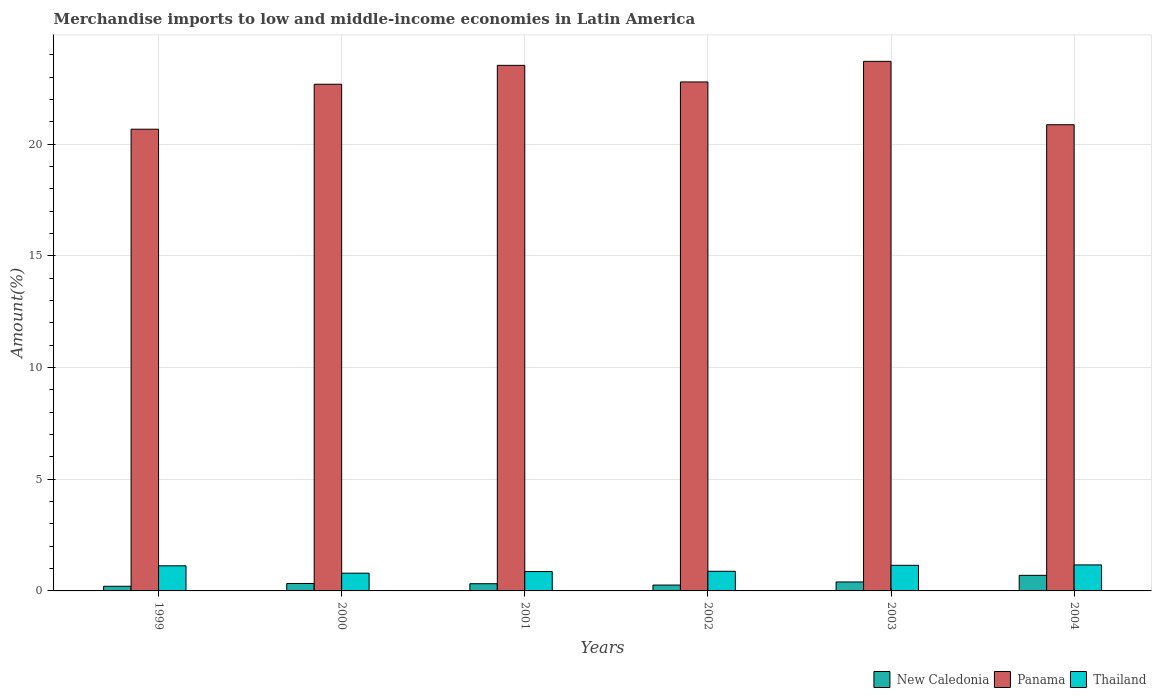How many different coloured bars are there?
Provide a short and direct response. 3. How many groups of bars are there?
Offer a terse response. 6. Are the number of bars per tick equal to the number of legend labels?
Your answer should be very brief. Yes. How many bars are there on the 3rd tick from the left?
Offer a terse response. 3. What is the percentage of amount earned from merchandise imports in New Caledonia in 2002?
Provide a short and direct response. 0.26. Across all years, what is the maximum percentage of amount earned from merchandise imports in Thailand?
Ensure brevity in your answer.  1.16. Across all years, what is the minimum percentage of amount earned from merchandise imports in Thailand?
Offer a very short reply. 0.79. In which year was the percentage of amount earned from merchandise imports in Thailand maximum?
Offer a very short reply. 2004. What is the total percentage of amount earned from merchandise imports in New Caledonia in the graph?
Your answer should be compact. 2.23. What is the difference between the percentage of amount earned from merchandise imports in Thailand in 2003 and that in 2004?
Your answer should be very brief. -0.02. What is the difference between the percentage of amount earned from merchandise imports in Panama in 2000 and the percentage of amount earned from merchandise imports in New Caledonia in 2003?
Keep it short and to the point. 22.28. What is the average percentage of amount earned from merchandise imports in New Caledonia per year?
Give a very brief answer. 0.37. In the year 2002, what is the difference between the percentage of amount earned from merchandise imports in Thailand and percentage of amount earned from merchandise imports in New Caledonia?
Make the answer very short. 0.62. In how many years, is the percentage of amount earned from merchandise imports in Thailand greater than 3 %?
Give a very brief answer. 0. What is the ratio of the percentage of amount earned from merchandise imports in New Caledonia in 2002 to that in 2003?
Your response must be concise. 0.66. Is the percentage of amount earned from merchandise imports in Panama in 2000 less than that in 2004?
Make the answer very short. No. Is the difference between the percentage of amount earned from merchandise imports in Thailand in 2003 and 2004 greater than the difference between the percentage of amount earned from merchandise imports in New Caledonia in 2003 and 2004?
Ensure brevity in your answer.  Yes. What is the difference between the highest and the second highest percentage of amount earned from merchandise imports in Panama?
Give a very brief answer. 0.18. What is the difference between the highest and the lowest percentage of amount earned from merchandise imports in Thailand?
Your response must be concise. 0.37. What does the 1st bar from the left in 2000 represents?
Provide a succinct answer. New Caledonia. What does the 2nd bar from the right in 2001 represents?
Give a very brief answer. Panama. How many years are there in the graph?
Provide a short and direct response. 6. Does the graph contain any zero values?
Offer a terse response. No. Does the graph contain grids?
Offer a terse response. Yes. What is the title of the graph?
Your answer should be very brief. Merchandise imports to low and middle-income economies in Latin America. Does "Montenegro" appear as one of the legend labels in the graph?
Keep it short and to the point. No. What is the label or title of the Y-axis?
Make the answer very short. Amount(%). What is the Amount(%) of New Caledonia in 1999?
Offer a terse response. 0.21. What is the Amount(%) of Panama in 1999?
Make the answer very short. 20.67. What is the Amount(%) in Thailand in 1999?
Offer a terse response. 1.12. What is the Amount(%) in New Caledonia in 2000?
Offer a terse response. 0.33. What is the Amount(%) in Panama in 2000?
Your response must be concise. 22.68. What is the Amount(%) of Thailand in 2000?
Your response must be concise. 0.79. What is the Amount(%) in New Caledonia in 2001?
Ensure brevity in your answer.  0.32. What is the Amount(%) of Panama in 2001?
Your answer should be very brief. 23.52. What is the Amount(%) of Thailand in 2001?
Provide a succinct answer. 0.87. What is the Amount(%) of New Caledonia in 2002?
Your answer should be very brief. 0.26. What is the Amount(%) in Panama in 2002?
Give a very brief answer. 22.78. What is the Amount(%) in Thailand in 2002?
Give a very brief answer. 0.88. What is the Amount(%) in New Caledonia in 2003?
Keep it short and to the point. 0.4. What is the Amount(%) of Panama in 2003?
Ensure brevity in your answer.  23.7. What is the Amount(%) in Thailand in 2003?
Your answer should be compact. 1.15. What is the Amount(%) of New Caledonia in 2004?
Offer a terse response. 0.7. What is the Amount(%) in Panama in 2004?
Offer a terse response. 20.87. What is the Amount(%) in Thailand in 2004?
Offer a very short reply. 1.16. Across all years, what is the maximum Amount(%) of New Caledonia?
Offer a very short reply. 0.7. Across all years, what is the maximum Amount(%) of Panama?
Your answer should be very brief. 23.7. Across all years, what is the maximum Amount(%) in Thailand?
Make the answer very short. 1.16. Across all years, what is the minimum Amount(%) in New Caledonia?
Give a very brief answer. 0.21. Across all years, what is the minimum Amount(%) of Panama?
Offer a terse response. 20.67. Across all years, what is the minimum Amount(%) of Thailand?
Make the answer very short. 0.79. What is the total Amount(%) of New Caledonia in the graph?
Your response must be concise. 2.23. What is the total Amount(%) in Panama in the graph?
Give a very brief answer. 134.22. What is the total Amount(%) of Thailand in the graph?
Offer a terse response. 5.98. What is the difference between the Amount(%) in New Caledonia in 1999 and that in 2000?
Provide a succinct answer. -0.13. What is the difference between the Amount(%) in Panama in 1999 and that in 2000?
Your answer should be very brief. -2.01. What is the difference between the Amount(%) of Thailand in 1999 and that in 2000?
Make the answer very short. 0.33. What is the difference between the Amount(%) of New Caledonia in 1999 and that in 2001?
Your answer should be very brief. -0.11. What is the difference between the Amount(%) in Panama in 1999 and that in 2001?
Your response must be concise. -2.86. What is the difference between the Amount(%) of Thailand in 1999 and that in 2001?
Your answer should be compact. 0.26. What is the difference between the Amount(%) of New Caledonia in 1999 and that in 2002?
Offer a terse response. -0.05. What is the difference between the Amount(%) of Panama in 1999 and that in 2002?
Provide a succinct answer. -2.12. What is the difference between the Amount(%) in Thailand in 1999 and that in 2002?
Provide a short and direct response. 0.24. What is the difference between the Amount(%) in New Caledonia in 1999 and that in 2003?
Ensure brevity in your answer.  -0.19. What is the difference between the Amount(%) of Panama in 1999 and that in 2003?
Keep it short and to the point. -3.04. What is the difference between the Amount(%) in Thailand in 1999 and that in 2003?
Provide a short and direct response. -0.02. What is the difference between the Amount(%) in New Caledonia in 1999 and that in 2004?
Offer a very short reply. -0.49. What is the difference between the Amount(%) of Panama in 1999 and that in 2004?
Give a very brief answer. -0.2. What is the difference between the Amount(%) of Thailand in 1999 and that in 2004?
Provide a short and direct response. -0.04. What is the difference between the Amount(%) of New Caledonia in 2000 and that in 2001?
Your answer should be compact. 0.01. What is the difference between the Amount(%) of Panama in 2000 and that in 2001?
Your answer should be very brief. -0.85. What is the difference between the Amount(%) of Thailand in 2000 and that in 2001?
Your response must be concise. -0.07. What is the difference between the Amount(%) of New Caledonia in 2000 and that in 2002?
Offer a very short reply. 0.07. What is the difference between the Amount(%) in Panama in 2000 and that in 2002?
Your answer should be very brief. -0.1. What is the difference between the Amount(%) of Thailand in 2000 and that in 2002?
Make the answer very short. -0.08. What is the difference between the Amount(%) of New Caledonia in 2000 and that in 2003?
Your response must be concise. -0.07. What is the difference between the Amount(%) in Panama in 2000 and that in 2003?
Your answer should be compact. -1.02. What is the difference between the Amount(%) in Thailand in 2000 and that in 2003?
Your response must be concise. -0.35. What is the difference between the Amount(%) in New Caledonia in 2000 and that in 2004?
Give a very brief answer. -0.36. What is the difference between the Amount(%) of Panama in 2000 and that in 2004?
Give a very brief answer. 1.81. What is the difference between the Amount(%) in Thailand in 2000 and that in 2004?
Offer a very short reply. -0.37. What is the difference between the Amount(%) of New Caledonia in 2001 and that in 2002?
Your answer should be compact. 0.06. What is the difference between the Amount(%) in Panama in 2001 and that in 2002?
Keep it short and to the point. 0.74. What is the difference between the Amount(%) in Thailand in 2001 and that in 2002?
Provide a short and direct response. -0.01. What is the difference between the Amount(%) of New Caledonia in 2001 and that in 2003?
Your answer should be very brief. -0.08. What is the difference between the Amount(%) of Panama in 2001 and that in 2003?
Your answer should be very brief. -0.18. What is the difference between the Amount(%) of Thailand in 2001 and that in 2003?
Give a very brief answer. -0.28. What is the difference between the Amount(%) in New Caledonia in 2001 and that in 2004?
Provide a succinct answer. -0.38. What is the difference between the Amount(%) in Panama in 2001 and that in 2004?
Make the answer very short. 2.66. What is the difference between the Amount(%) in Thailand in 2001 and that in 2004?
Provide a short and direct response. -0.3. What is the difference between the Amount(%) of New Caledonia in 2002 and that in 2003?
Offer a very short reply. -0.14. What is the difference between the Amount(%) in Panama in 2002 and that in 2003?
Ensure brevity in your answer.  -0.92. What is the difference between the Amount(%) of Thailand in 2002 and that in 2003?
Provide a short and direct response. -0.27. What is the difference between the Amount(%) of New Caledonia in 2002 and that in 2004?
Keep it short and to the point. -0.43. What is the difference between the Amount(%) of Panama in 2002 and that in 2004?
Keep it short and to the point. 1.92. What is the difference between the Amount(%) in Thailand in 2002 and that in 2004?
Make the answer very short. -0.28. What is the difference between the Amount(%) of New Caledonia in 2003 and that in 2004?
Ensure brevity in your answer.  -0.3. What is the difference between the Amount(%) in Panama in 2003 and that in 2004?
Offer a very short reply. 2.84. What is the difference between the Amount(%) of Thailand in 2003 and that in 2004?
Provide a succinct answer. -0.02. What is the difference between the Amount(%) of New Caledonia in 1999 and the Amount(%) of Panama in 2000?
Your answer should be compact. -22.47. What is the difference between the Amount(%) of New Caledonia in 1999 and the Amount(%) of Thailand in 2000?
Offer a terse response. -0.59. What is the difference between the Amount(%) of Panama in 1999 and the Amount(%) of Thailand in 2000?
Offer a very short reply. 19.87. What is the difference between the Amount(%) in New Caledonia in 1999 and the Amount(%) in Panama in 2001?
Keep it short and to the point. -23.32. What is the difference between the Amount(%) in New Caledonia in 1999 and the Amount(%) in Thailand in 2001?
Give a very brief answer. -0.66. What is the difference between the Amount(%) in Panama in 1999 and the Amount(%) in Thailand in 2001?
Your answer should be very brief. 19.8. What is the difference between the Amount(%) in New Caledonia in 1999 and the Amount(%) in Panama in 2002?
Your response must be concise. -22.57. What is the difference between the Amount(%) of New Caledonia in 1999 and the Amount(%) of Thailand in 2002?
Provide a short and direct response. -0.67. What is the difference between the Amount(%) of Panama in 1999 and the Amount(%) of Thailand in 2002?
Provide a short and direct response. 19.79. What is the difference between the Amount(%) of New Caledonia in 1999 and the Amount(%) of Panama in 2003?
Provide a short and direct response. -23.5. What is the difference between the Amount(%) in New Caledonia in 1999 and the Amount(%) in Thailand in 2003?
Your answer should be very brief. -0.94. What is the difference between the Amount(%) in Panama in 1999 and the Amount(%) in Thailand in 2003?
Keep it short and to the point. 19.52. What is the difference between the Amount(%) in New Caledonia in 1999 and the Amount(%) in Panama in 2004?
Your response must be concise. -20.66. What is the difference between the Amount(%) of New Caledonia in 1999 and the Amount(%) of Thailand in 2004?
Your answer should be compact. -0.96. What is the difference between the Amount(%) in Panama in 1999 and the Amount(%) in Thailand in 2004?
Offer a very short reply. 19.5. What is the difference between the Amount(%) in New Caledonia in 2000 and the Amount(%) in Panama in 2001?
Your response must be concise. -23.19. What is the difference between the Amount(%) of New Caledonia in 2000 and the Amount(%) of Thailand in 2001?
Ensure brevity in your answer.  -0.53. What is the difference between the Amount(%) of Panama in 2000 and the Amount(%) of Thailand in 2001?
Offer a very short reply. 21.81. What is the difference between the Amount(%) of New Caledonia in 2000 and the Amount(%) of Panama in 2002?
Your answer should be very brief. -22.45. What is the difference between the Amount(%) in New Caledonia in 2000 and the Amount(%) in Thailand in 2002?
Keep it short and to the point. -0.55. What is the difference between the Amount(%) of Panama in 2000 and the Amount(%) of Thailand in 2002?
Provide a succinct answer. 21.8. What is the difference between the Amount(%) in New Caledonia in 2000 and the Amount(%) in Panama in 2003?
Provide a succinct answer. -23.37. What is the difference between the Amount(%) of New Caledonia in 2000 and the Amount(%) of Thailand in 2003?
Ensure brevity in your answer.  -0.81. What is the difference between the Amount(%) in Panama in 2000 and the Amount(%) in Thailand in 2003?
Your response must be concise. 21.53. What is the difference between the Amount(%) of New Caledonia in 2000 and the Amount(%) of Panama in 2004?
Your answer should be very brief. -20.53. What is the difference between the Amount(%) of New Caledonia in 2000 and the Amount(%) of Thailand in 2004?
Offer a very short reply. -0.83. What is the difference between the Amount(%) of Panama in 2000 and the Amount(%) of Thailand in 2004?
Your answer should be very brief. 21.52. What is the difference between the Amount(%) in New Caledonia in 2001 and the Amount(%) in Panama in 2002?
Offer a very short reply. -22.46. What is the difference between the Amount(%) of New Caledonia in 2001 and the Amount(%) of Thailand in 2002?
Your response must be concise. -0.56. What is the difference between the Amount(%) in Panama in 2001 and the Amount(%) in Thailand in 2002?
Provide a short and direct response. 22.65. What is the difference between the Amount(%) in New Caledonia in 2001 and the Amount(%) in Panama in 2003?
Provide a succinct answer. -23.38. What is the difference between the Amount(%) in New Caledonia in 2001 and the Amount(%) in Thailand in 2003?
Offer a very short reply. -0.82. What is the difference between the Amount(%) in Panama in 2001 and the Amount(%) in Thailand in 2003?
Your response must be concise. 22.38. What is the difference between the Amount(%) of New Caledonia in 2001 and the Amount(%) of Panama in 2004?
Give a very brief answer. -20.54. What is the difference between the Amount(%) of New Caledonia in 2001 and the Amount(%) of Thailand in 2004?
Your response must be concise. -0.84. What is the difference between the Amount(%) in Panama in 2001 and the Amount(%) in Thailand in 2004?
Offer a very short reply. 22.36. What is the difference between the Amount(%) in New Caledonia in 2002 and the Amount(%) in Panama in 2003?
Your answer should be compact. -23.44. What is the difference between the Amount(%) in New Caledonia in 2002 and the Amount(%) in Thailand in 2003?
Offer a terse response. -0.88. What is the difference between the Amount(%) in Panama in 2002 and the Amount(%) in Thailand in 2003?
Offer a very short reply. 21.64. What is the difference between the Amount(%) of New Caledonia in 2002 and the Amount(%) of Panama in 2004?
Give a very brief answer. -20.6. What is the difference between the Amount(%) in New Caledonia in 2002 and the Amount(%) in Thailand in 2004?
Your response must be concise. -0.9. What is the difference between the Amount(%) in Panama in 2002 and the Amount(%) in Thailand in 2004?
Ensure brevity in your answer.  21.62. What is the difference between the Amount(%) in New Caledonia in 2003 and the Amount(%) in Panama in 2004?
Your answer should be very brief. -20.47. What is the difference between the Amount(%) in New Caledonia in 2003 and the Amount(%) in Thailand in 2004?
Your answer should be very brief. -0.76. What is the difference between the Amount(%) of Panama in 2003 and the Amount(%) of Thailand in 2004?
Provide a succinct answer. 22.54. What is the average Amount(%) in New Caledonia per year?
Make the answer very short. 0.37. What is the average Amount(%) in Panama per year?
Keep it short and to the point. 22.37. What is the average Amount(%) in Thailand per year?
Your answer should be compact. 1. In the year 1999, what is the difference between the Amount(%) in New Caledonia and Amount(%) in Panama?
Provide a short and direct response. -20.46. In the year 1999, what is the difference between the Amount(%) in New Caledonia and Amount(%) in Thailand?
Your answer should be compact. -0.92. In the year 1999, what is the difference between the Amount(%) of Panama and Amount(%) of Thailand?
Ensure brevity in your answer.  19.54. In the year 2000, what is the difference between the Amount(%) in New Caledonia and Amount(%) in Panama?
Your answer should be very brief. -22.35. In the year 2000, what is the difference between the Amount(%) of New Caledonia and Amount(%) of Thailand?
Provide a succinct answer. -0.46. In the year 2000, what is the difference between the Amount(%) in Panama and Amount(%) in Thailand?
Make the answer very short. 21.88. In the year 2001, what is the difference between the Amount(%) in New Caledonia and Amount(%) in Panama?
Your answer should be very brief. -23.2. In the year 2001, what is the difference between the Amount(%) in New Caledonia and Amount(%) in Thailand?
Give a very brief answer. -0.54. In the year 2001, what is the difference between the Amount(%) of Panama and Amount(%) of Thailand?
Keep it short and to the point. 22.66. In the year 2002, what is the difference between the Amount(%) of New Caledonia and Amount(%) of Panama?
Keep it short and to the point. -22.52. In the year 2002, what is the difference between the Amount(%) of New Caledonia and Amount(%) of Thailand?
Offer a very short reply. -0.62. In the year 2002, what is the difference between the Amount(%) in Panama and Amount(%) in Thailand?
Provide a short and direct response. 21.9. In the year 2003, what is the difference between the Amount(%) of New Caledonia and Amount(%) of Panama?
Your answer should be compact. -23.3. In the year 2003, what is the difference between the Amount(%) in New Caledonia and Amount(%) in Thailand?
Your response must be concise. -0.75. In the year 2003, what is the difference between the Amount(%) in Panama and Amount(%) in Thailand?
Make the answer very short. 22.56. In the year 2004, what is the difference between the Amount(%) in New Caledonia and Amount(%) in Panama?
Offer a very short reply. -20.17. In the year 2004, what is the difference between the Amount(%) in New Caledonia and Amount(%) in Thailand?
Offer a terse response. -0.47. In the year 2004, what is the difference between the Amount(%) in Panama and Amount(%) in Thailand?
Your response must be concise. 19.7. What is the ratio of the Amount(%) in New Caledonia in 1999 to that in 2000?
Provide a succinct answer. 0.62. What is the ratio of the Amount(%) in Panama in 1999 to that in 2000?
Ensure brevity in your answer.  0.91. What is the ratio of the Amount(%) in Thailand in 1999 to that in 2000?
Provide a short and direct response. 1.41. What is the ratio of the Amount(%) in New Caledonia in 1999 to that in 2001?
Provide a succinct answer. 0.65. What is the ratio of the Amount(%) of Panama in 1999 to that in 2001?
Provide a succinct answer. 0.88. What is the ratio of the Amount(%) of Thailand in 1999 to that in 2001?
Your response must be concise. 1.3. What is the ratio of the Amount(%) of New Caledonia in 1999 to that in 2002?
Your answer should be very brief. 0.79. What is the ratio of the Amount(%) in Panama in 1999 to that in 2002?
Offer a very short reply. 0.91. What is the ratio of the Amount(%) in Thailand in 1999 to that in 2002?
Ensure brevity in your answer.  1.28. What is the ratio of the Amount(%) of New Caledonia in 1999 to that in 2003?
Make the answer very short. 0.52. What is the ratio of the Amount(%) in Panama in 1999 to that in 2003?
Offer a terse response. 0.87. What is the ratio of the Amount(%) of Thailand in 1999 to that in 2003?
Make the answer very short. 0.98. What is the ratio of the Amount(%) in New Caledonia in 1999 to that in 2004?
Offer a very short reply. 0.3. What is the ratio of the Amount(%) of Panama in 1999 to that in 2004?
Your answer should be very brief. 0.99. What is the ratio of the Amount(%) of Thailand in 1999 to that in 2004?
Make the answer very short. 0.97. What is the ratio of the Amount(%) in New Caledonia in 2000 to that in 2001?
Provide a succinct answer. 1.03. What is the ratio of the Amount(%) in Panama in 2000 to that in 2001?
Ensure brevity in your answer.  0.96. What is the ratio of the Amount(%) in Thailand in 2000 to that in 2001?
Your response must be concise. 0.92. What is the ratio of the Amount(%) of New Caledonia in 2000 to that in 2002?
Provide a succinct answer. 1.27. What is the ratio of the Amount(%) of Thailand in 2000 to that in 2002?
Make the answer very short. 0.9. What is the ratio of the Amount(%) in New Caledonia in 2000 to that in 2003?
Offer a terse response. 0.83. What is the ratio of the Amount(%) of Panama in 2000 to that in 2003?
Provide a succinct answer. 0.96. What is the ratio of the Amount(%) in Thailand in 2000 to that in 2003?
Give a very brief answer. 0.69. What is the ratio of the Amount(%) of New Caledonia in 2000 to that in 2004?
Give a very brief answer. 0.48. What is the ratio of the Amount(%) in Panama in 2000 to that in 2004?
Provide a succinct answer. 1.09. What is the ratio of the Amount(%) of Thailand in 2000 to that in 2004?
Provide a short and direct response. 0.68. What is the ratio of the Amount(%) in New Caledonia in 2001 to that in 2002?
Ensure brevity in your answer.  1.23. What is the ratio of the Amount(%) of Panama in 2001 to that in 2002?
Your response must be concise. 1.03. What is the ratio of the Amount(%) of Thailand in 2001 to that in 2002?
Provide a short and direct response. 0.99. What is the ratio of the Amount(%) of New Caledonia in 2001 to that in 2003?
Keep it short and to the point. 0.8. What is the ratio of the Amount(%) in Thailand in 2001 to that in 2003?
Your answer should be very brief. 0.76. What is the ratio of the Amount(%) in New Caledonia in 2001 to that in 2004?
Your answer should be very brief. 0.46. What is the ratio of the Amount(%) in Panama in 2001 to that in 2004?
Your response must be concise. 1.13. What is the ratio of the Amount(%) of Thailand in 2001 to that in 2004?
Provide a short and direct response. 0.75. What is the ratio of the Amount(%) of New Caledonia in 2002 to that in 2003?
Your answer should be compact. 0.66. What is the ratio of the Amount(%) of Panama in 2002 to that in 2003?
Your answer should be compact. 0.96. What is the ratio of the Amount(%) of Thailand in 2002 to that in 2003?
Your answer should be very brief. 0.77. What is the ratio of the Amount(%) in New Caledonia in 2002 to that in 2004?
Your response must be concise. 0.38. What is the ratio of the Amount(%) in Panama in 2002 to that in 2004?
Your response must be concise. 1.09. What is the ratio of the Amount(%) of Thailand in 2002 to that in 2004?
Your answer should be very brief. 0.76. What is the ratio of the Amount(%) of New Caledonia in 2003 to that in 2004?
Offer a terse response. 0.57. What is the ratio of the Amount(%) of Panama in 2003 to that in 2004?
Keep it short and to the point. 1.14. What is the ratio of the Amount(%) in Thailand in 2003 to that in 2004?
Give a very brief answer. 0.99. What is the difference between the highest and the second highest Amount(%) in New Caledonia?
Offer a terse response. 0.3. What is the difference between the highest and the second highest Amount(%) of Panama?
Give a very brief answer. 0.18. What is the difference between the highest and the second highest Amount(%) in Thailand?
Offer a very short reply. 0.02. What is the difference between the highest and the lowest Amount(%) in New Caledonia?
Provide a short and direct response. 0.49. What is the difference between the highest and the lowest Amount(%) of Panama?
Your answer should be very brief. 3.04. What is the difference between the highest and the lowest Amount(%) in Thailand?
Your response must be concise. 0.37. 